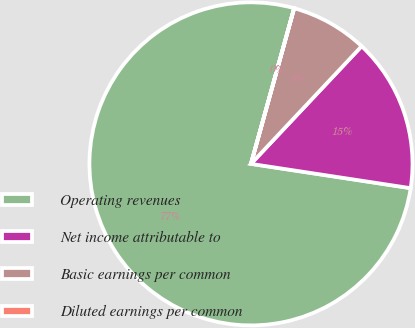Convert chart. <chart><loc_0><loc_0><loc_500><loc_500><pie_chart><fcel>Operating revenues<fcel>Net income attributable to<fcel>Basic earnings per common<fcel>Diluted earnings per common<nl><fcel>76.9%<fcel>15.39%<fcel>7.7%<fcel>0.01%<nl></chart> 